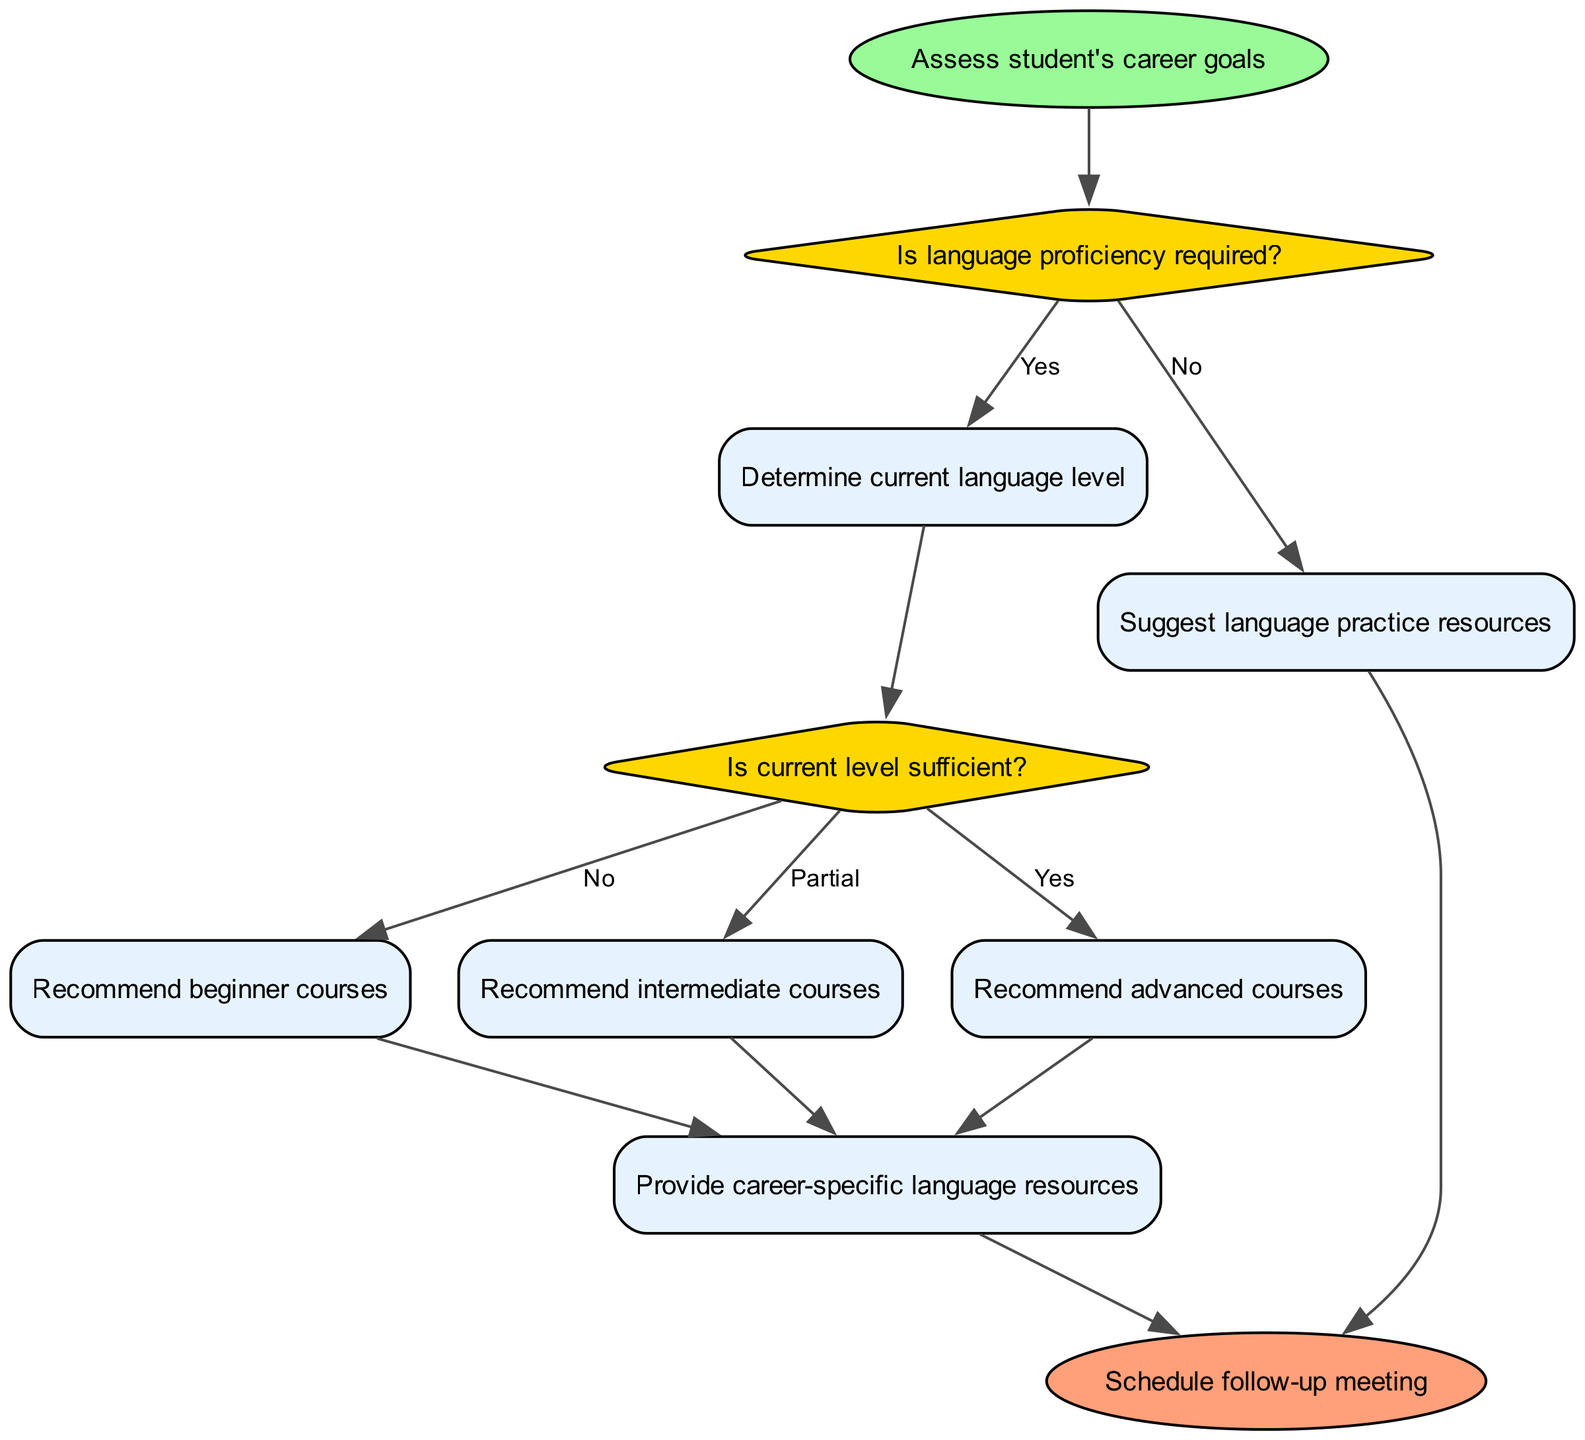What is the first step in the procedure? The procedure begins with the first action node that states "Assess student's career goals" as the starting point.
Answer: Assess student's career goals How many decision nodes are in the diagram? By inspecting the diagram, we can see there are two decision nodes labeled "Is language proficiency required?" and "Is current level sufficient?".
Answer: 2 What action follows if the answer to the first decision is "Yes"? The flow indicates that if the answer to the first decision "Is language proficiency required?" is "Yes", it proceeds to the action node "Determine current language level".
Answer: Determine current language level What happens if the current language level is sufficient? According to the flow, if the current language level is sufficient, it leads to the action node "Recommend advanced courses".
Answer: Recommend advanced courses What resource is suggested if language proficiency is not required? The diagram shows that if language proficiency is not required, it leads to the action node "Suggest language practice resources".
Answer: Suggest language practice resources What is the last action taken in the process? The end of the process is represented by the last action node, which is "Schedule follow-up meeting".
Answer: Schedule follow-up meeting If the current level is only partial, what action does the diagram recommend? In the case where the current language level is partial, the recommendation follows to the action node "Recommend intermediate courses".
Answer: Recommend intermediate courses What action is common to all paths leading to career-specific resources? All paths that lead to "Provide career-specific language resources" originate from the action nodes "Recommend beginner courses", "Recommend intermediate courses", or "Recommend advanced courses".
Answer: Provide career-specific language resources 